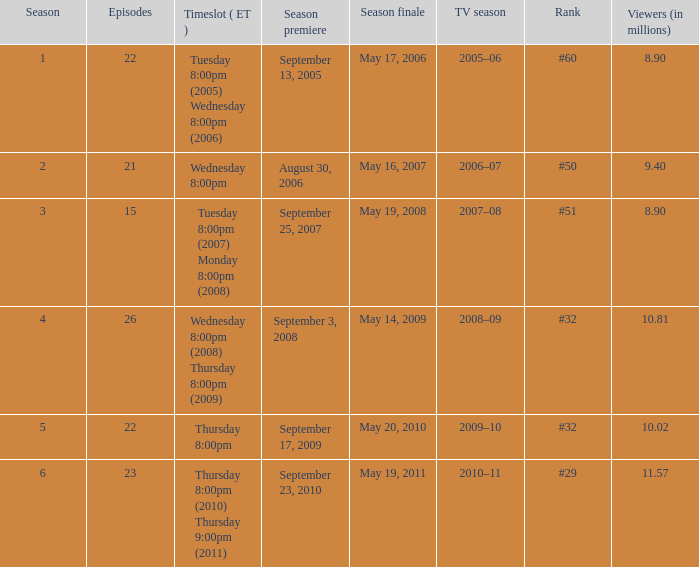In how many seasons did the rank reach #50? 1.0. 